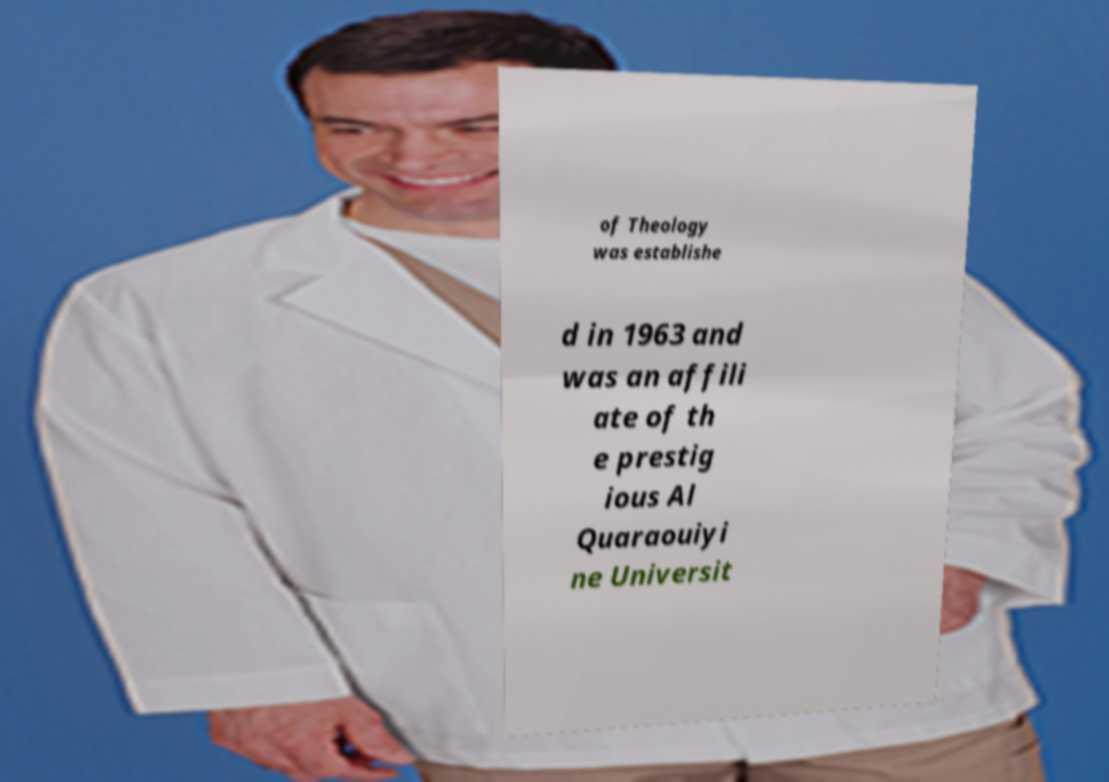Could you assist in decoding the text presented in this image and type it out clearly? of Theology was establishe d in 1963 and was an affili ate of th e prestig ious Al Quaraouiyi ne Universit 